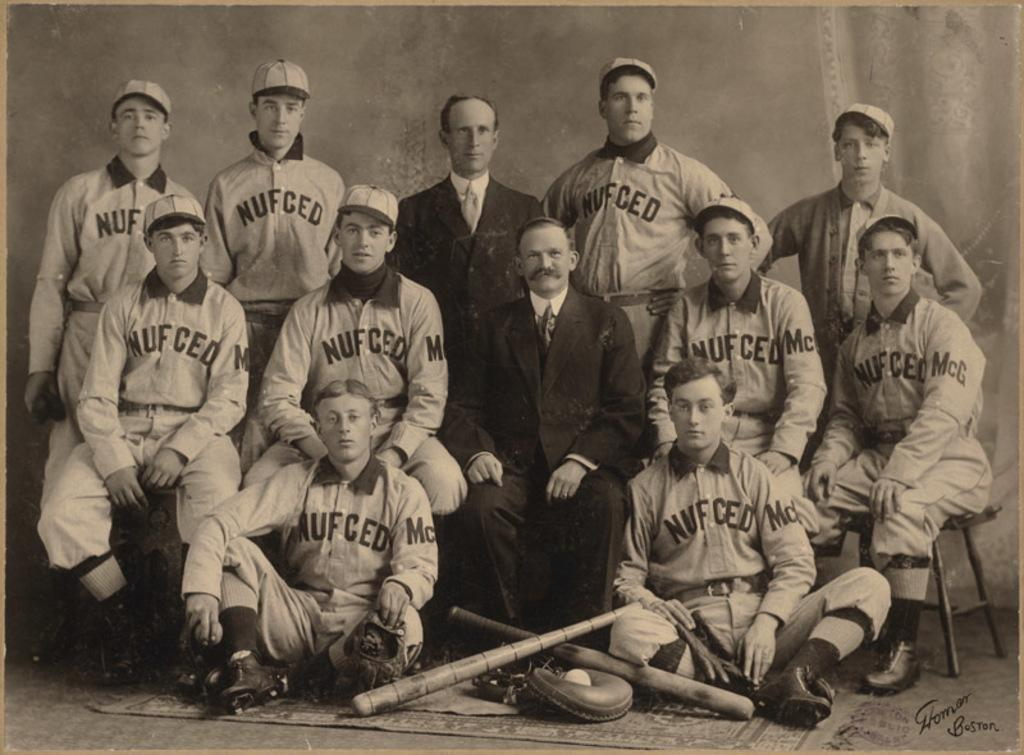<image>
Share a concise interpretation of the image provided. A team photo of the Nufced baseball team. 